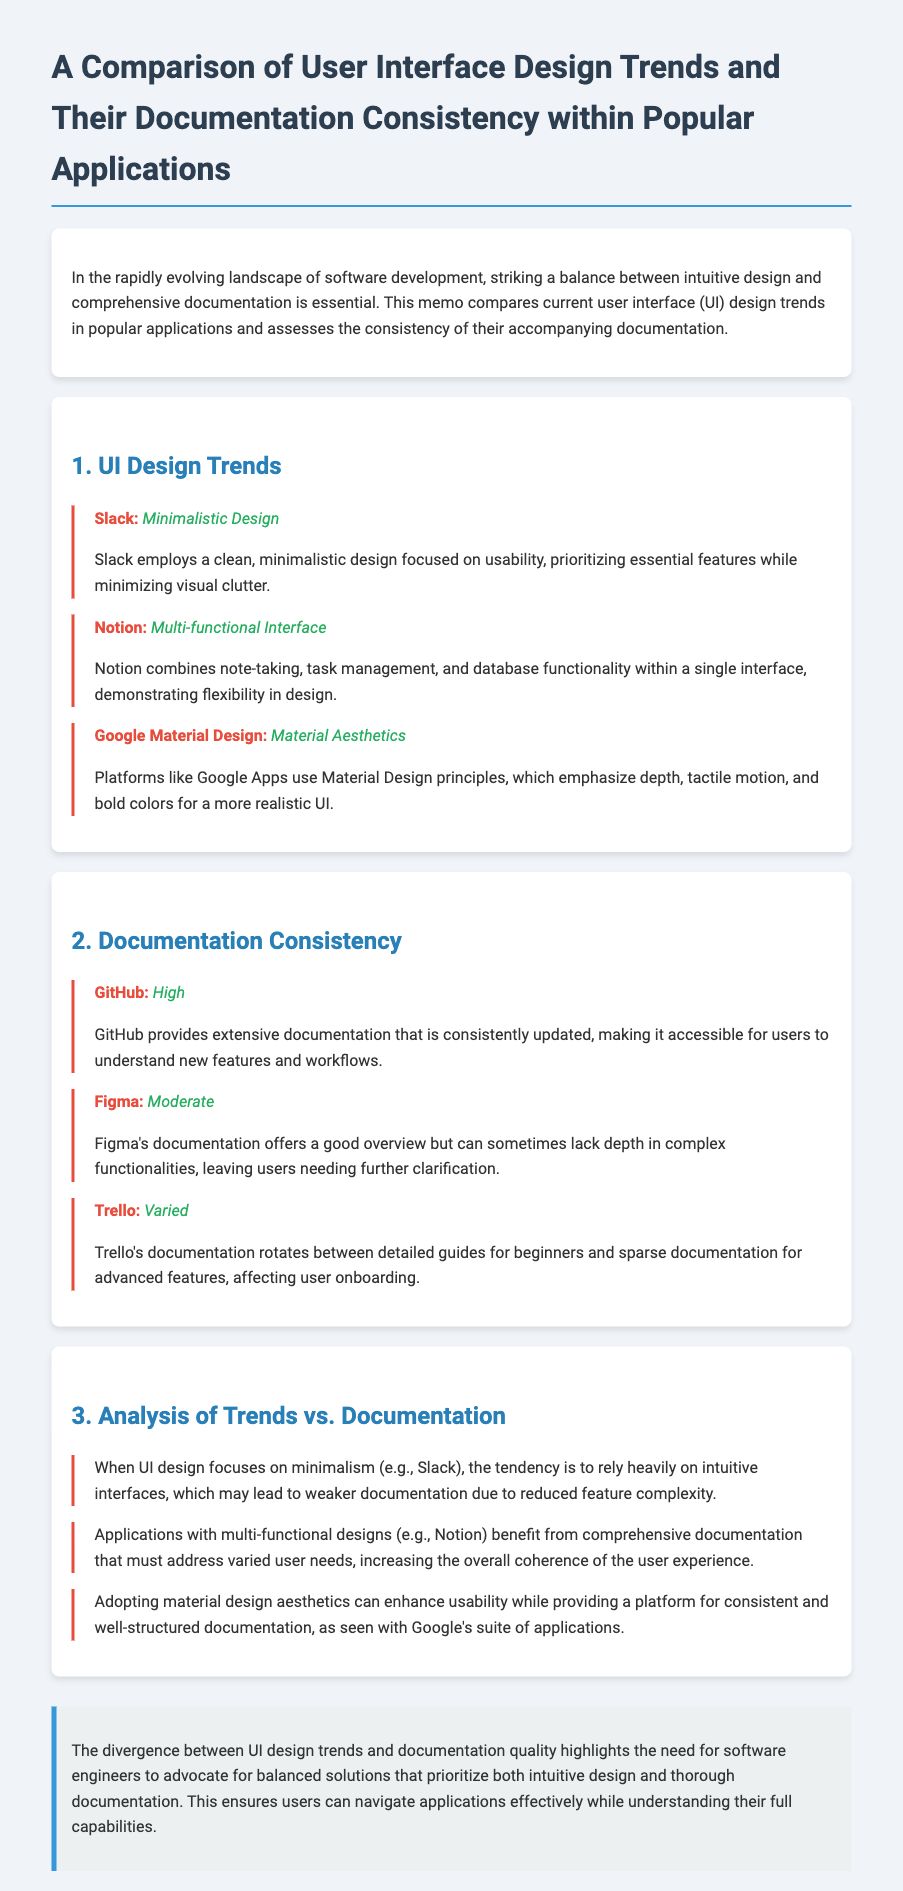What is the title of the memo? The title of the memo is explicitly stated at the top of the document.
Answer: A Comparison of User Interface Design Trends and Their Documentation Consistency within Popular Applications Which application uses a minimalistic design? The memo specifies that Slack employs a minimalistic design, as noted in the UI Design Trends section.
Answer: Slack What is the documentation quality of GitHub? The documentation quality of GitHub is stated clearly in the Documentation Consistency section.
Answer: High Which application combines note-taking, task management, and database functionality? The memo identifies Notion as the application with this functionality in the UI Design Trends section.
Answer: Notion What observation is made about minimalist UI design regarding documentation? The text explains a relationship between minimalist design and documentation in the Analysis of Trends vs. Documentation section.
Answer: Weaker documentation What trend is associated with Google Apps? The memo specifically mentions the design trend associated with Google Apps in the UI Design Trends section.
Answer: Material Aesthetics What is the documentation quality of Trello? The memo clearly indicates the documentation quality for Trello in the Documentation Consistency section.
Answer: Varied What is a key conclusion drawn in the memo? The final part of the memo summarizes the important takeaways regarding the balance of design and documentation.
Answer: Balanced solutions 